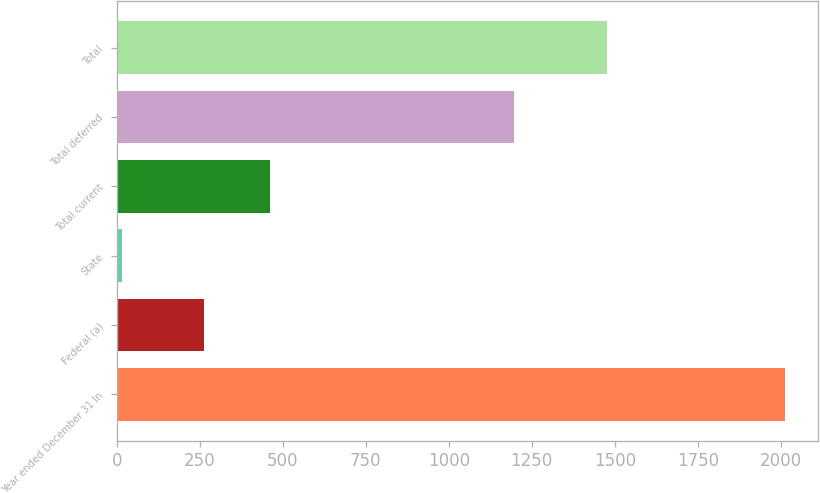Convert chart. <chart><loc_0><loc_0><loc_500><loc_500><bar_chart><fcel>Year ended December 31 In<fcel>Federal (a)<fcel>State<fcel>Total current<fcel>Total deferred<fcel>Total<nl><fcel>2013<fcel>263<fcel>17<fcel>462.6<fcel>1196<fcel>1476<nl></chart> 